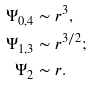<formula> <loc_0><loc_0><loc_500><loc_500>\Psi _ { 0 , 4 } & \sim r ^ { 3 } , \\ \Psi _ { 1 , 3 } & \sim r ^ { 3 / 2 } ; \\ \Psi _ { 2 } & \sim r .</formula> 